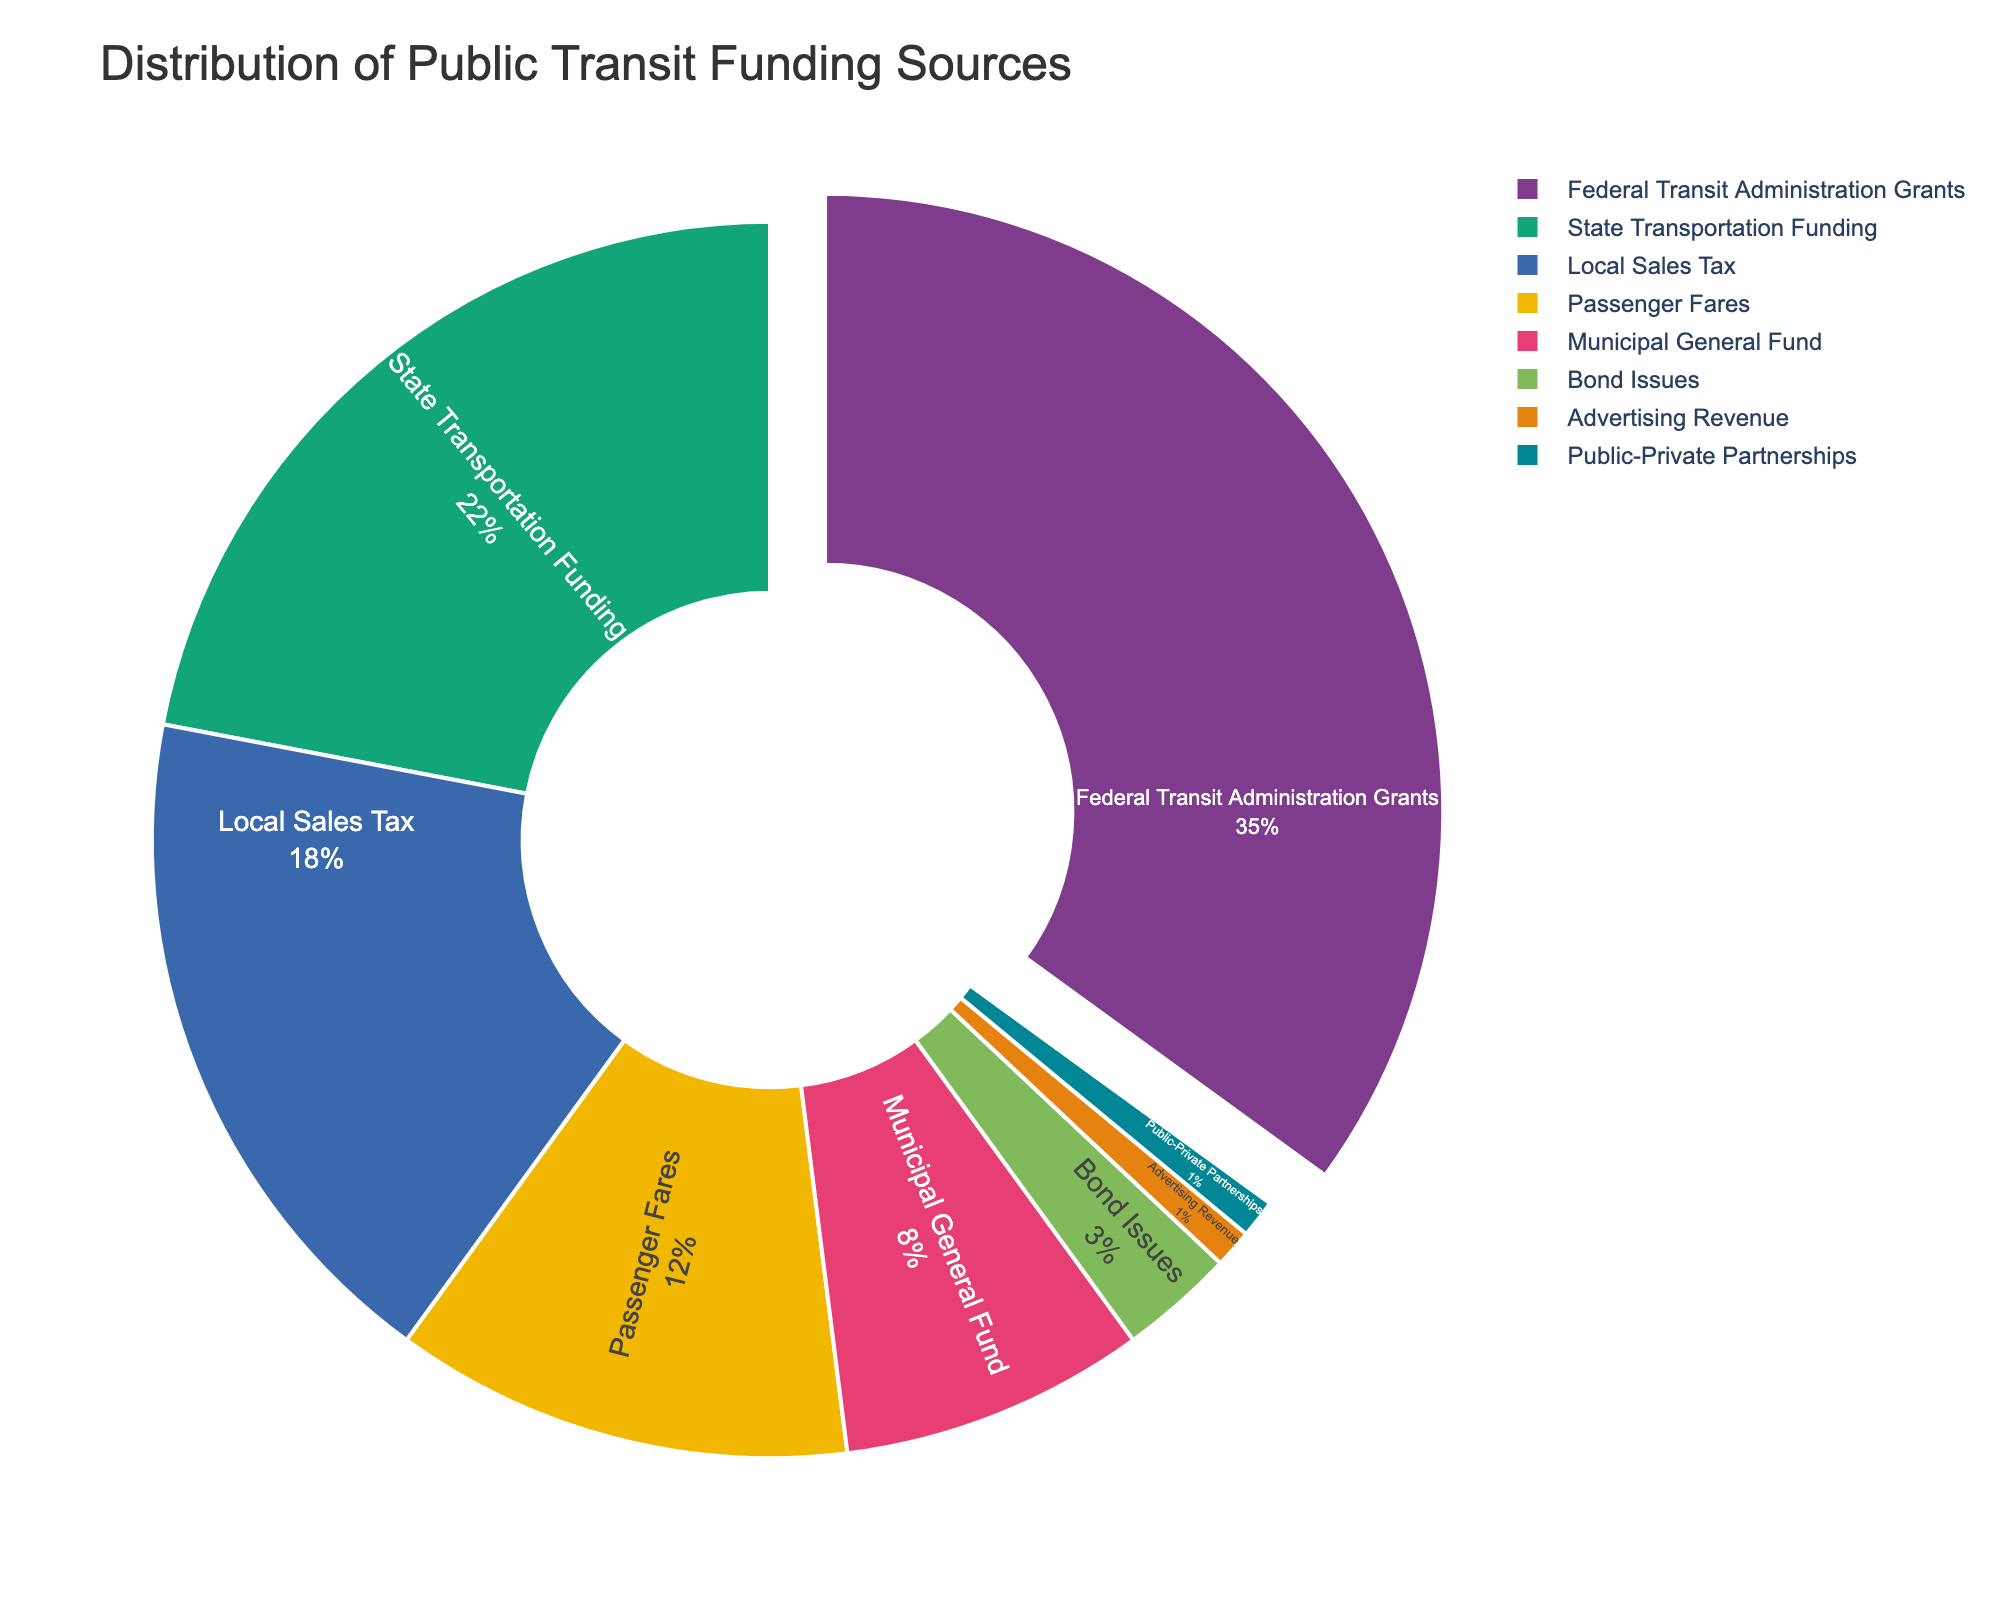Which funding source contributes the largest percentage to public transit funding? The largest slice of the pie chart represents the funding source contributing the most significant percentage. The Federal Transit Administration Grants sector is the largest, indicating it contributes the most.
Answer: Federal Transit Administration Grants Which funding sources contribute less than 5% each to the total public transit funding? By examining the pie chart, the smallest sectors representing Bond Issues, Advertising Revenue, and Public-Private Partnerships each contribute less than 5%.
Answer: Bond Issues, Advertising Revenue, Public-Private Partnerships What is the combined percentage of Local Sales Tax and Passenger Fares? Locate the Local Sales Tax and Passenger Fares slices in the pie chart and add their percentages: 18% (Local Sales Tax) + 12% (Passenger Fares) = 30%.
Answer: 30% How much more percentage does Federal Transit Administration Grants contribute compared to State Transportation Funding? Subtract the percentage of State Transportation Funding from Federal Transit Administration Grants: 35% - 22% = 13%.
Answer: 13% Which funding source is represented by the slice directly pulled out of the pie chart? The slice that is pulled out of the pie chart is highlighted as the most significant contributor. The Federal Transit Administration Grants slice is pulled out.
Answer: Federal Transit Administration Grants How do the combined percentages of Local Sales Tax and Municipal General Fund compare to the percentage of State Transportation Funding? Add the percentages of Local Sales Tax and Municipal General Fund: 18% + 8% = 26%. Compare this to State Transportation Funding’s 22%.
Answer: Local Sales Tax and Municipal General Fund combined is greater Which funding source has a smaller contribution, Passenger Fares or Bond Issues? By comparing the sizes of the slices, Passenger Fares (12%) and Bond Issues (3%), Bond Issues have a smaller percentage.
Answer: Bond Issues What is the total percentage contributed by non-federal sources? Sum all percentages except Federal Transit Administration Grants: 22% + 18% + 12% + 8% + 3% + 1% + 1% = 65%.
Answer: 65% Which sources have equal contributions to public transit funding? Identify slices of the same size; both Advertising Revenue and Public-Private Partnerships contribute 1% each.
Answer: Advertising Revenue and Public-Private Partnerships 